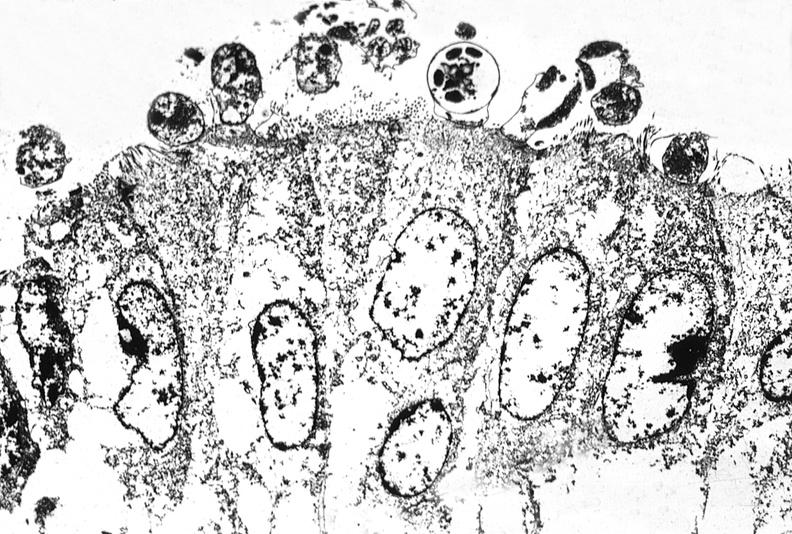where is this electron microscopy figure taken?
Answer the question using a single word or phrase. Gastrointestinal system 